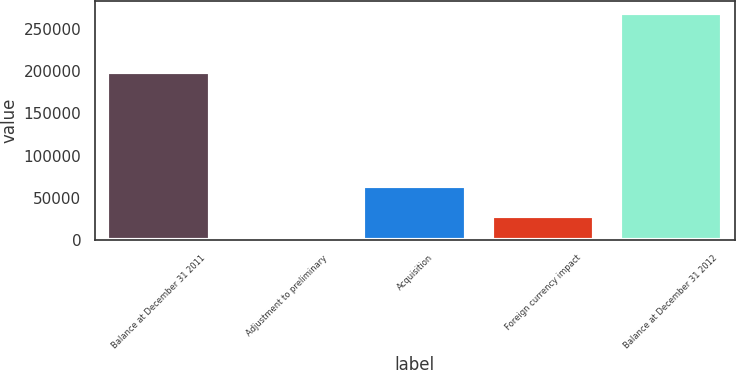Convert chart to OTSL. <chart><loc_0><loc_0><loc_500><loc_500><bar_chart><fcel>Balance at December 31 2011<fcel>Adjustment to preliminary<fcel>Acquisition<fcel>Foreign currency impact<fcel>Balance at December 31 2012<nl><fcel>199310<fcel>1364<fcel>63505<fcel>28111.4<fcel>268838<nl></chart> 